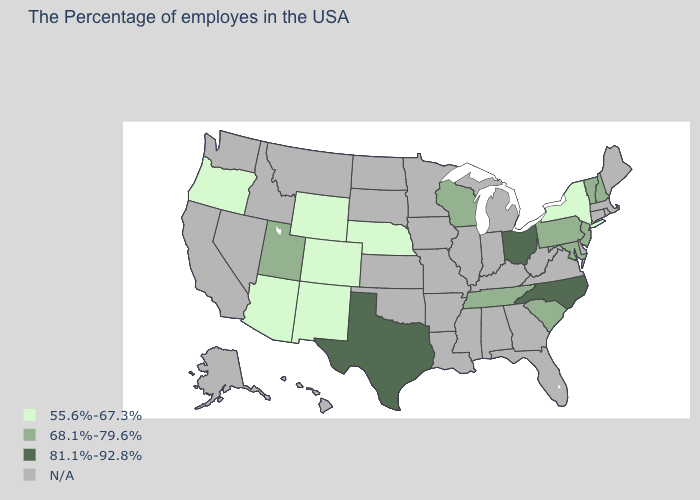What is the value of South Carolina?
Give a very brief answer. 68.1%-79.6%. What is the lowest value in the West?
Write a very short answer. 55.6%-67.3%. What is the value of Rhode Island?
Answer briefly. N/A. Which states have the lowest value in the USA?
Be succinct. New York, Nebraska, Wyoming, Colorado, New Mexico, Arizona, Oregon. What is the value of South Carolina?
Concise answer only. 68.1%-79.6%. Does the map have missing data?
Be succinct. Yes. What is the lowest value in the USA?
Write a very short answer. 55.6%-67.3%. Among the states that border Michigan , which have the lowest value?
Concise answer only. Wisconsin. Name the states that have a value in the range N/A?
Answer briefly. Maine, Massachusetts, Rhode Island, Connecticut, Delaware, Virginia, West Virginia, Florida, Georgia, Michigan, Kentucky, Indiana, Alabama, Illinois, Mississippi, Louisiana, Missouri, Arkansas, Minnesota, Iowa, Kansas, Oklahoma, South Dakota, North Dakota, Montana, Idaho, Nevada, California, Washington, Alaska, Hawaii. What is the value of Arkansas?
Concise answer only. N/A. What is the value of Minnesota?
Answer briefly. N/A. What is the highest value in states that border Maine?
Concise answer only. 68.1%-79.6%. Name the states that have a value in the range 81.1%-92.8%?
Keep it brief. North Carolina, Ohio, Texas. Name the states that have a value in the range 68.1%-79.6%?
Concise answer only. New Hampshire, Vermont, New Jersey, Maryland, Pennsylvania, South Carolina, Tennessee, Wisconsin, Utah. What is the value of Colorado?
Quick response, please. 55.6%-67.3%. 